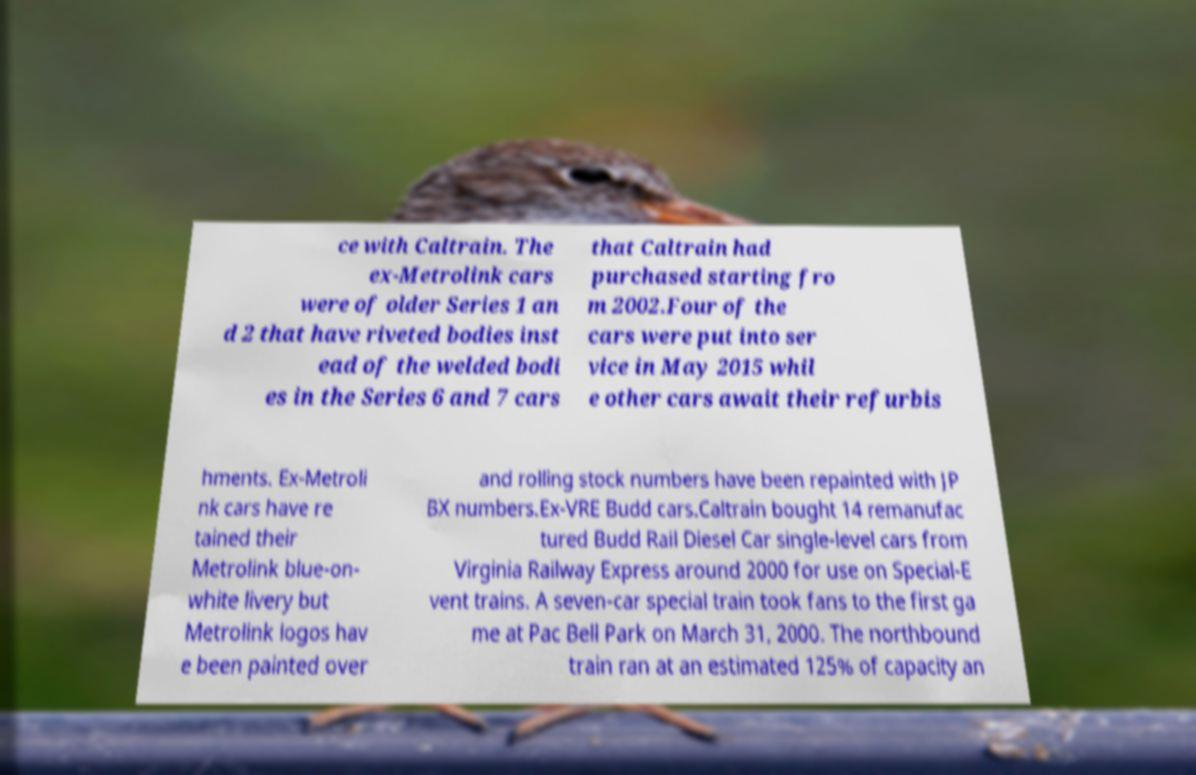For documentation purposes, I need the text within this image transcribed. Could you provide that? ce with Caltrain. The ex-Metrolink cars were of older Series 1 an d 2 that have riveted bodies inst ead of the welded bodi es in the Series 6 and 7 cars that Caltrain had purchased starting fro m 2002.Four of the cars were put into ser vice in May 2015 whil e other cars await their refurbis hments. Ex-Metroli nk cars have re tained their Metrolink blue-on- white livery but Metrolink logos hav e been painted over and rolling stock numbers have been repainted with JP BX numbers.Ex-VRE Budd cars.Caltrain bought 14 remanufac tured Budd Rail Diesel Car single-level cars from Virginia Railway Express around 2000 for use on Special-E vent trains. A seven-car special train took fans to the first ga me at Pac Bell Park on March 31, 2000. The northbound train ran at an estimated 125% of capacity an 